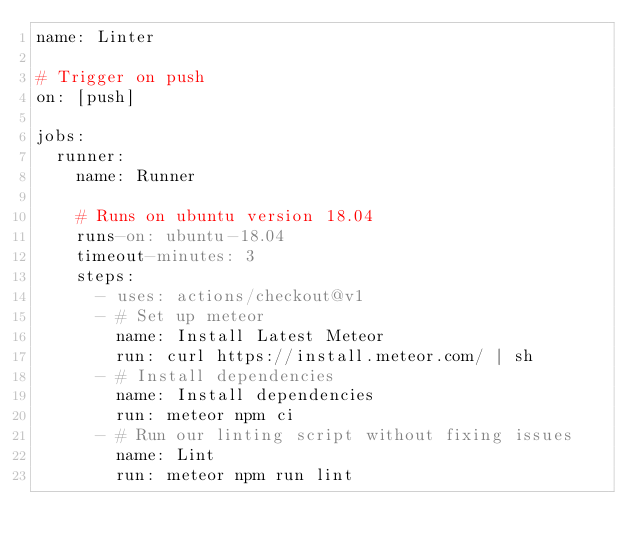<code> <loc_0><loc_0><loc_500><loc_500><_YAML_>name: Linter

# Trigger on push
on: [push]

jobs:
  runner:
    name: Runner

    # Runs on ubuntu version 18.04
    runs-on: ubuntu-18.04
    timeout-minutes: 3
    steps:
      - uses: actions/checkout@v1
      - # Set up meteor
        name: Install Latest Meteor
        run: curl https://install.meteor.com/ | sh
      - # Install dependencies
        name: Install dependencies
        run: meteor npm ci
      - # Run our linting script without fixing issues
        name: Lint
        run: meteor npm run lint
</code> 